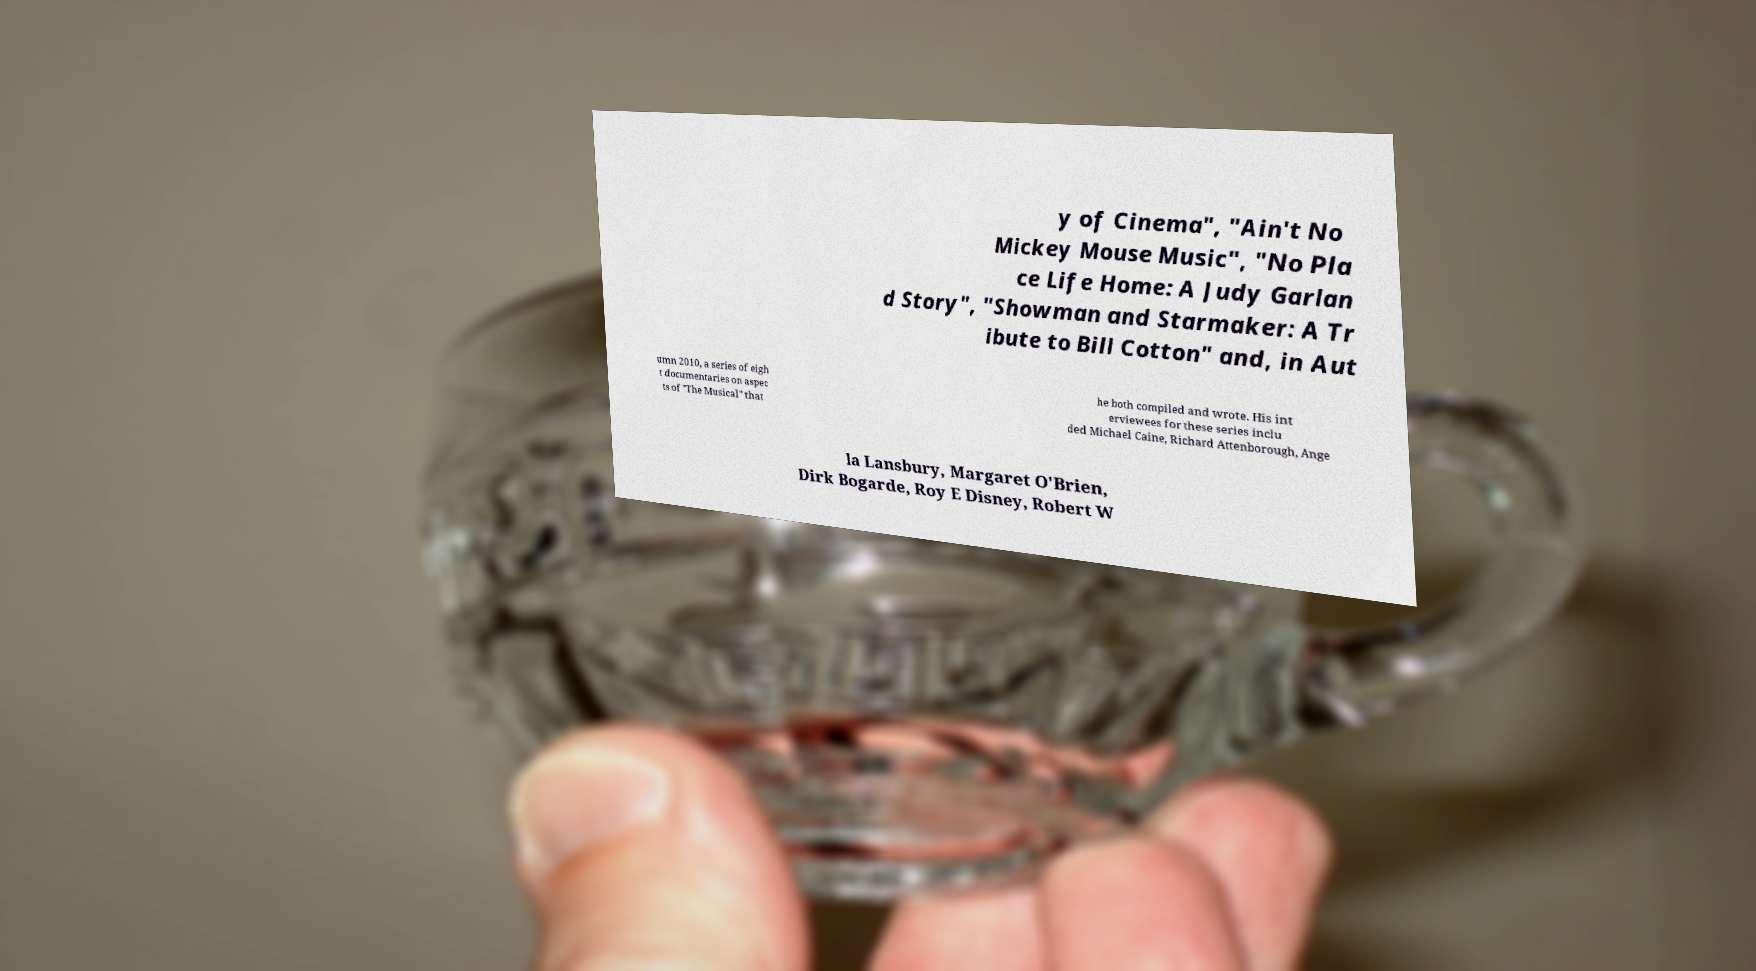There's text embedded in this image that I need extracted. Can you transcribe it verbatim? y of Cinema", "Ain't No Mickey Mouse Music", "No Pla ce Life Home: A Judy Garlan d Story", "Showman and Starmaker: A Tr ibute to Bill Cotton" and, in Aut umn 2010, a series of eigh t documentaries on aspec ts of "The Musical" that he both compiled and wrote. His int erviewees for these series inclu ded Michael Caine, Richard Attenborough, Ange la Lansbury, Margaret O'Brien, Dirk Bogarde, Roy E Disney, Robert W 